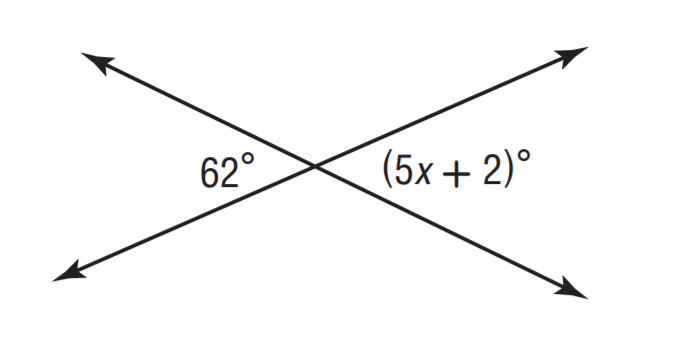Question: Solve for x.
Choices:
A. 9
B. 10
C. 11
D. 12
Answer with the letter. Answer: D 